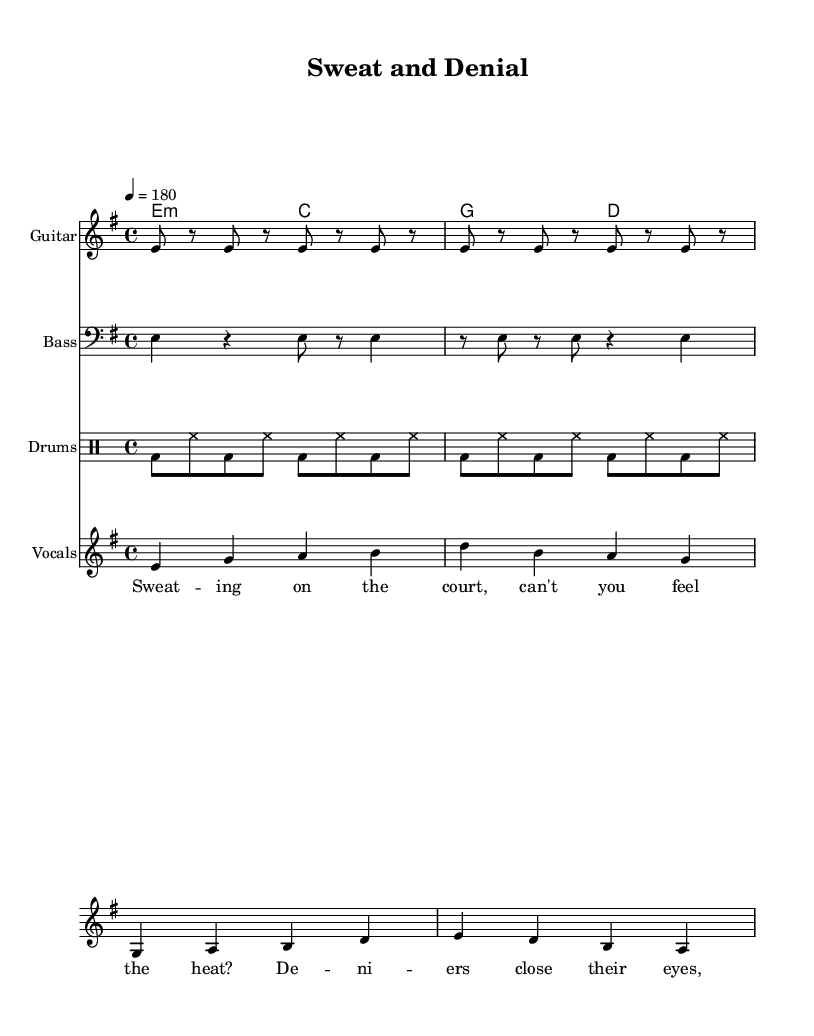What is the key signature of this music? The key signature shown is E minor, which has one sharp (F#).
Answer: E minor What is the time signature of this music? The time signature indicated at the beginning is 4/4, meaning there are four beats in a measure.
Answer: 4/4 What is the tempo marking of the piece? The tempo marking states "4 = 180," which means there are 180 beats per minute.
Answer: 180 How many measures are in the guitar riff? The guitar riff consists of two repeated sections, each containing four measures, totaling eight measures overall.
Answer: 8 What is the main theme of the lyrics? The lyrics center around the consequences of climate change denial on outdoor sports, particularly emphasizing heat and its effect on basketball.
Answer: Climate change denial What chord progression is used in the chorus? The chorus uses the chord progression of G major to D major as seen in the harmony section.
Answer: G to D What type of instruments are featured in this music? The music features guitar, bass, drums, and vocals, typical for punk tracks which emphasize strong instrumentals and vocal delivery.
Answer: Guitar, bass, drums, vocals 